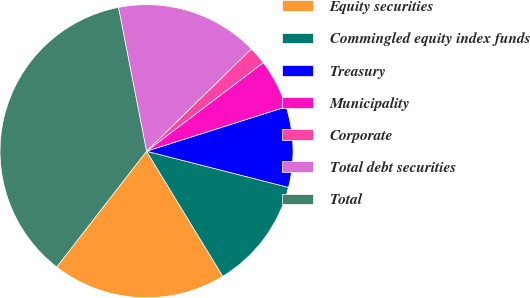Convert chart to OTSL. <chart><loc_0><loc_0><loc_500><loc_500><pie_chart><fcel>Equity securities<fcel>Commingled equity index funds<fcel>Treasury<fcel>Municipality<fcel>Corporate<fcel>Total debt securities<fcel>Total<nl><fcel>19.21%<fcel>12.32%<fcel>8.87%<fcel>5.43%<fcel>1.98%<fcel>15.76%<fcel>36.43%<nl></chart> 